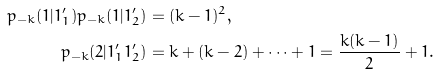<formula> <loc_0><loc_0><loc_500><loc_500>p _ { - k } ( 1 | 1 _ { 1 } ^ { \prime } ) p _ { - k } ( 1 | 1 _ { 2 } ^ { \prime } ) & = ( k - 1 ) ^ { 2 } , \\ p _ { - k } ( 2 | 1 _ { 1 } ^ { \prime } 1 _ { 2 } ^ { \prime } ) & = k + ( k - 2 ) + \cdots + 1 = \frac { k ( k - 1 ) } { 2 } + 1 .</formula> 